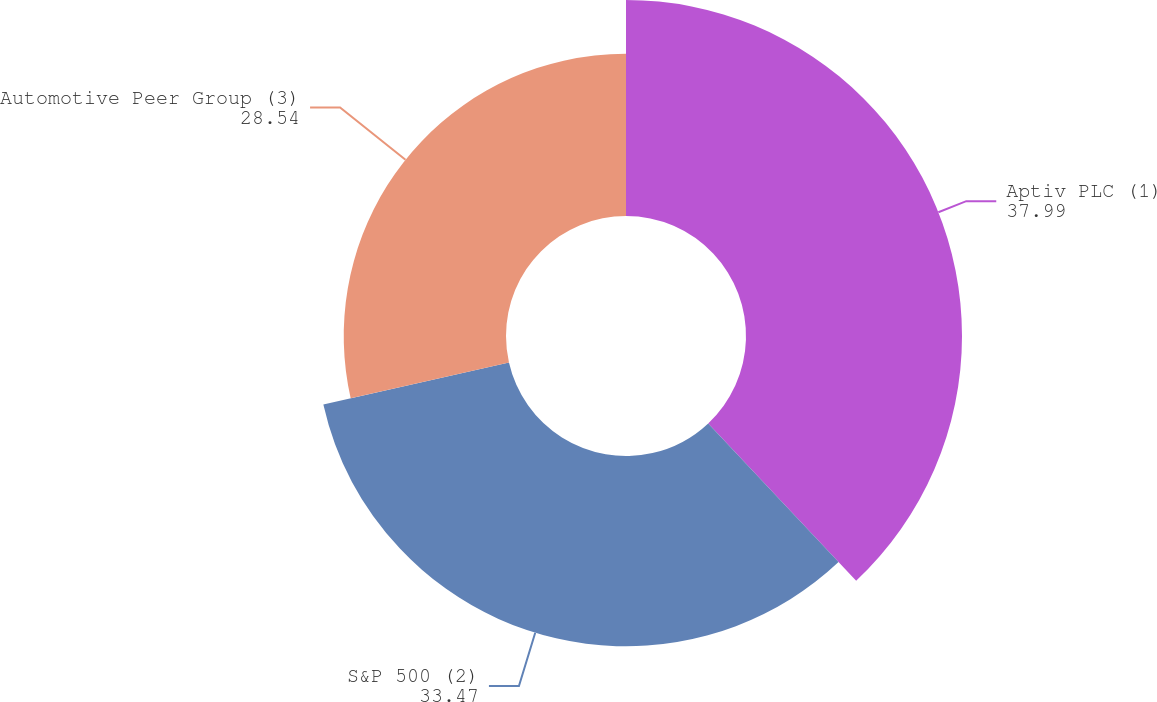Convert chart to OTSL. <chart><loc_0><loc_0><loc_500><loc_500><pie_chart><fcel>Aptiv PLC (1)<fcel>S&P 500 (2)<fcel>Automotive Peer Group (3)<nl><fcel>37.99%<fcel>33.47%<fcel>28.54%<nl></chart> 